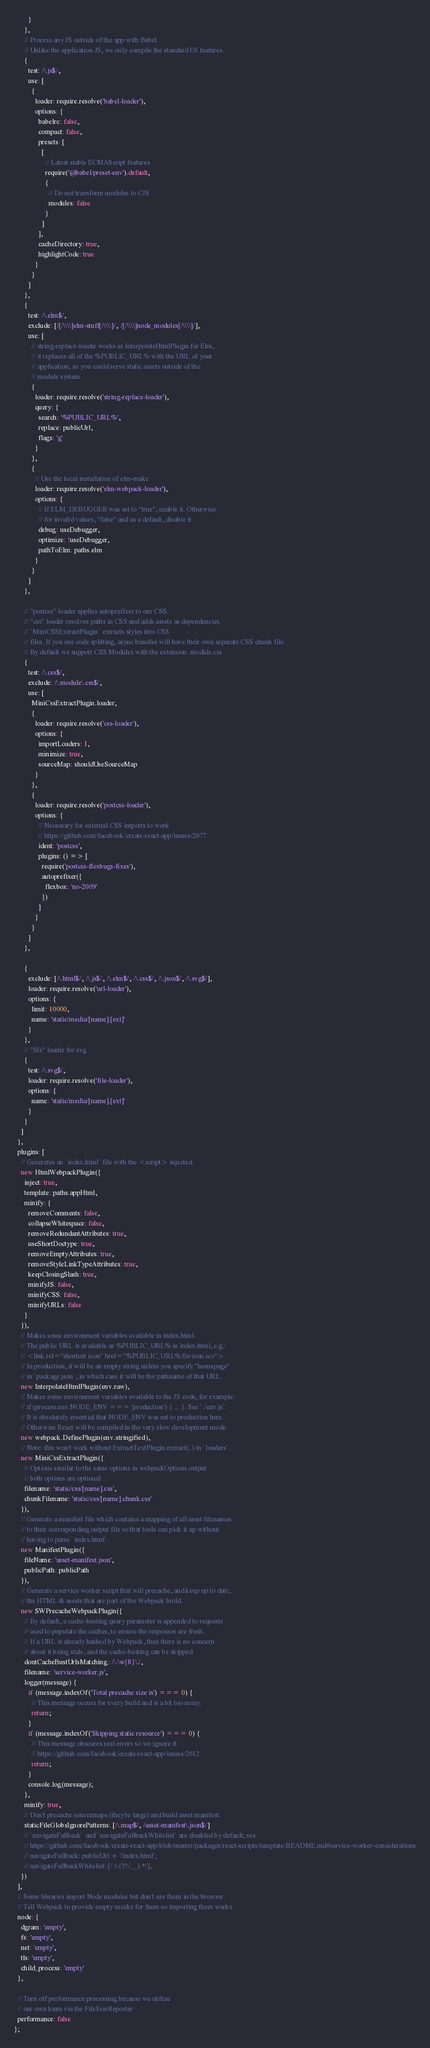Convert code to text. <code><loc_0><loc_0><loc_500><loc_500><_JavaScript_>        }
      },
      // Process any JS outside of the app with Babel.
      // Unlike the application JS, we only compile the standard ES features.
      {
        test: /\.js$/,
        use: [
          {
            loader: require.resolve('babel-loader'),
            options: {
              babelrc: false,
              compact: false,
              presets: [
                [
                  // Latest stable ECMAScript features
                  require('@babel/preset-env').default,
                  {
                    // Do not transform modules to CJS
                    modules: false
                  }
                ]
              ],
              cacheDirectory: true,
              highlightCode: true
            }
          }
        ]
      },
      {
        test: /\.elm$/,
        exclude: [/[/\\\\]elm-stuff[/\\\\]/, /[/\\\\]node_modules[/\\\\]/],
        use: [
          // string-replace-loader works as InterpolateHtmlPlugin for Elm,
          // it replaces all of the %PUBLIC_URL% with the URL of your
          // application, so you could serve static assets outside of the
          // module system.
          {
            loader: require.resolve('string-replace-loader'),
            query: {
              search: '%PUBLIC_URL%',
              replace: publicUrl,
              flags: 'g'
            }
          },
          {
            // Use the local installation of elm-make
            loader: require.resolve('elm-webpack-loader'),
            options: {
              // If ELM_DEBUGGER was set to "true", enable it. Otherwise
              // for invalid values, "false" and as a default, disable it
              debug: useDebugger,
              optimize: !useDebugger,
              pathToElm: paths.elm
            }
          }
        ]
      },

      // "postcss" loader applies autoprefixer to our CSS.
      // "css" loader resolves paths in CSS and adds assets as dependencies.
      // `MiniCSSExtractPlugin` extracts styles into CSS
      // files. If you use code splitting, async bundles will have their own separate CSS chunk file.
      // By default we support CSS Modules with the extension .module.css
      {
        test: /\.css$/,
        exclude: /\.module\.css$/,
        use: [
          MiniCssExtractPlugin.loader,
          {
            loader: require.resolve('css-loader'),
            options: {
              importLoaders: 1,
              minimize: true,
              sourceMap: shouldUseSourceMap
            }
          },
          {
            loader: require.resolve('postcss-loader'),
            options: {
              // Necessary for external CSS imports to work
              // https://github.com/facebook/create-react-app/issues/2677
              ident: 'postcss',
              plugins: () => [
                require('postcss-flexbugs-fixes'),
                autoprefixer({
                  flexbox: 'no-2009'
                })
              ]
            }
          }
        ]
      },

      {
        exclude: [/\.html$/, /\.js$/, /\.elm$/, /\.css$/, /\.json$/, /\.svg$/],
        loader: require.resolve('url-loader'),
        options: {
          limit: 10000,
          name: 'static/media/[name].[ext]'
        }
      },
      // "file" loader for svg
      {
        test: /\.svg$/,
        loader: require.resolve('file-loader'),
        options: {
          name: 'static/media/[name].[ext]'
        }
      }
    ]
  },
  plugins: [
    // Generates an `index.html` file with the <script> injected.
    new HtmlWebpackPlugin({
      inject: true,
      template: paths.appHtml,
      minify: {
        removeComments: false,
        collapseWhitespace: false,
        removeRedundantAttributes: true,
        useShortDoctype: true,
        removeEmptyAttributes: true,
        removeStyleLinkTypeAttributes: true,
        keepClosingSlash: true,
        minifyJS: false,
        minifyCSS: false,
        minifyURLs: false
      }
    }),
    // Makes some environment variables available in index.html.
    // The public URL is available as %PUBLIC_URL% in index.html, e.g.:
    // <link rel="shortcut icon" href="%PUBLIC_URL%/favicon.ico">
    // In production, it will be an empty string unless you specify "homepage"
    // in `package.json`, in which case it will be the pathname of that URL.
    new InterpolateHtmlPlugin(env.raw),
    // Makes some environment variables available to the JS code, for example:
    // if (process.env.NODE_ENV === 'production') { ... }. See `./env.js`.
    // It is absolutely essential that NODE_ENV was set to production here.
    // Otherwise React will be compiled in the very slow development mode.
    new webpack.DefinePlugin(env.stringified),
    // Note: this won't work without ExtractTextPlugin.extract(..) in `loaders`.
    new MiniCssExtractPlugin({
      // Options similar to the same options in webpackOptions.output
      // both options are optional
      filename: 'static/css/[name].css',
      chunkFilename: 'static/css/[name].chunk.css'
    }),
    // Generate a manifest file which contains a mapping of all asset filenames
    // to their corresponding output file so that tools can pick it up without
    // having to parse `index.html`.
    new ManifestPlugin({
      fileName: 'asset-manifest.json',
      publicPath: publicPath
    }),
    // Generate a service worker script that will precache, and keep up to date,
    // the HTML & assets that are part of the Webpack build.
    new SWPrecacheWebpackPlugin({
      // By default, a cache-busting query parameter is appended to requests
      // used to populate the caches, to ensure the responses are fresh.
      // If a URL is already hashed by Webpack, then there is no concern
      // about it being stale, and the cache-busting can be skipped.
      dontCacheBustUrlsMatching: /\.\w{8}\./,
      filename: 'service-worker.js',
      logger(message) {
        if (message.indexOf('Total precache size is') === 0) {
          // This message occurs for every build and is a bit too noisy.
          return;
        }
        if (message.indexOf('Skipping static resource') === 0) {
          // This message obscures real errors so we ignore it.
          // https://github.com/facebook/create-react-app/issues/2612
          return;
        }
        console.log(message);
      },
      minify: true,
      // Don't precache sourcemaps (they're large) and build asset manifest:
      staticFileGlobsIgnorePatterns: [/\.map$/, /asset-manifest\.json$/]
      // `navigateFallback` and `navigateFallbackWhitelist` are disabled by default; see
      // https://github.com/facebook/create-react-app/blob/master/packages/react-scripts/template/README.md#service-worker-considerations
      // navigateFallback: publicUrl + '/index.html',
      // navigateFallbackWhitelist: [/^(?!\/__).*/],
    })
  ],
  // Some libraries import Node modules but don't use them in the browser.
  // Tell Webpack to provide empty mocks for them so importing them works.
  node: {
    dgram: 'empty',
    fs: 'empty',
    net: 'empty',
    tls: 'empty',
    child_process: 'empty'
  },

  // Turn off performance processing because we utilize
  // our own hints via the FileSizeReporter
  performance: false
};
</code> 